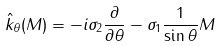<formula> <loc_0><loc_0><loc_500><loc_500>\hat { k } _ { \theta } ( M ) = - i \sigma _ { 2 } \frac { \partial } { \partial \theta } - \sigma _ { 1 } \frac { 1 } { \sin \theta } M</formula> 